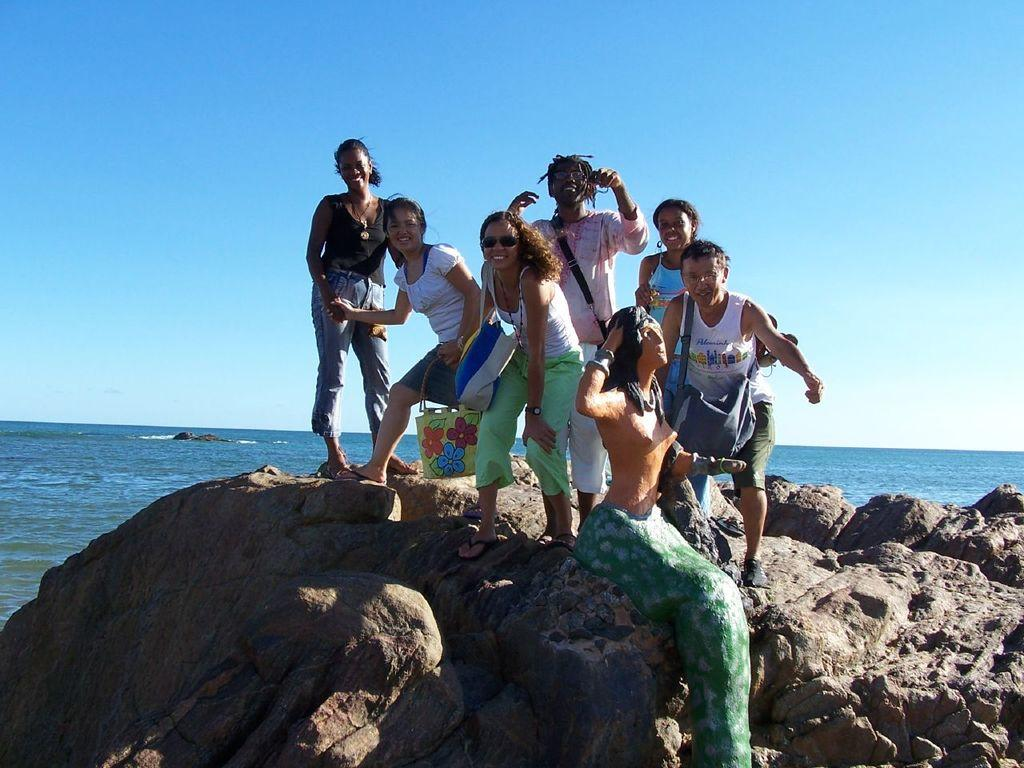How many people are in the image? There is a group of people in the image. What are the people doing in the image? The people are standing on rocks and smiling. What else can be seen in the image besides the people? There is a statue, bags, goggles, water, and the sky visible in the image. What type of fish can be seen swimming near the people in the image? There are no fish visible in the image; it features people standing on rocks, a statue, bags, goggles, water, and the sky. What tools might a carpenter use in the image? There is no carpenter or carpentry tools present in the image. How many beginner mistakes can be observed in the image? There is no indication of any mistakes, beginner or otherwise, in the image. 